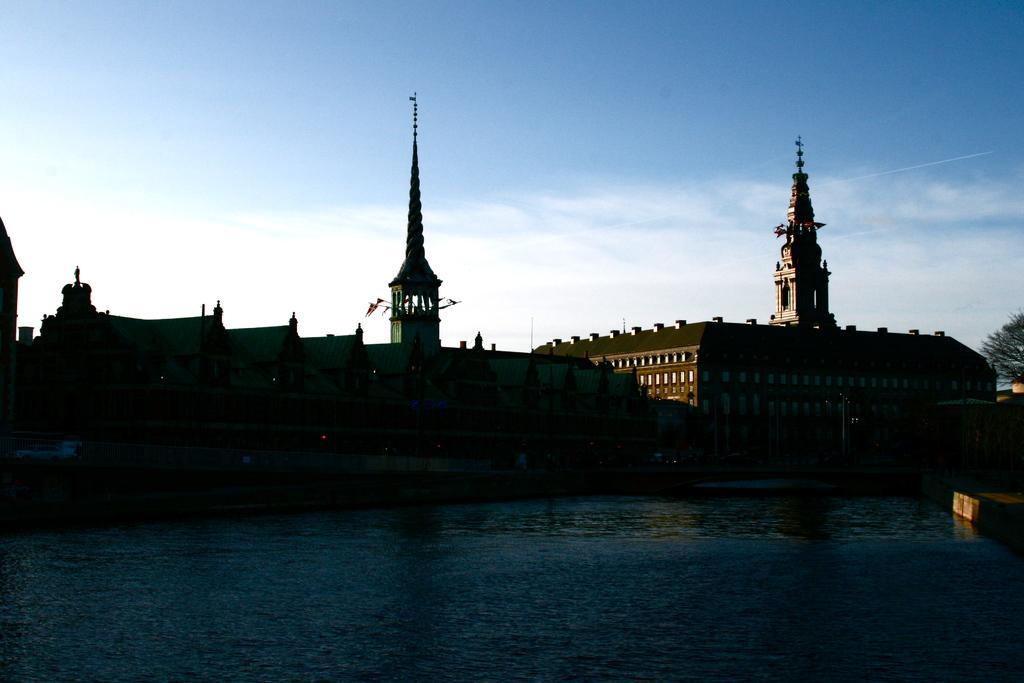Please provide a concise description of this image. In this picture we can see few buildings and a tree on the right side. Sky is blue in color and cloudy. 